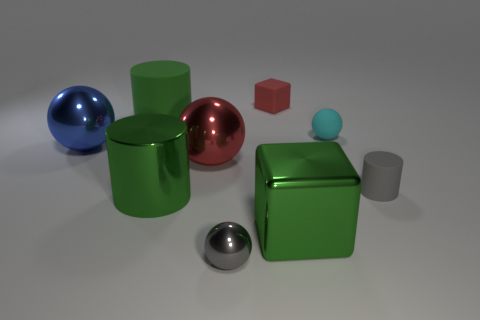Is there any other thing that has the same shape as the small gray matte object? Yes, the small gray matte object appears to be cylindrical, and there is another object with a similar shape—the blue metallic object on the left. Both share a cylindrical shape but differ in size, color, and surface finish. 